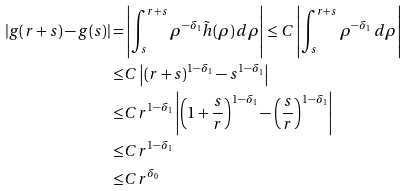<formula> <loc_0><loc_0><loc_500><loc_500>| g ( r + s ) - g ( s ) | = & \left | \int _ { s } ^ { r + s } \rho ^ { - \delta _ { 1 } } \tilde { h } ( \rho ) \, d \rho \right | \leq C \left | \int _ { s } ^ { r + s } \rho ^ { - \delta _ { 1 } } \, d \rho \right | \\ \leq & C \left | \left ( r + s \right ) ^ { 1 - \delta _ { 1 } } - s ^ { 1 - \delta _ { 1 } } \right | \\ \leq & C r ^ { 1 - \delta _ { 1 } } \left | \left ( 1 + \frac { s } { r } \right ) ^ { 1 - \delta _ { 1 } } - \left ( \frac { s } { r } \right ) ^ { 1 - \delta _ { 1 } } \right | \\ \leq & C r ^ { 1 - \delta _ { 1 } } \\ \leq & C r ^ { \delta _ { 0 } }</formula> 